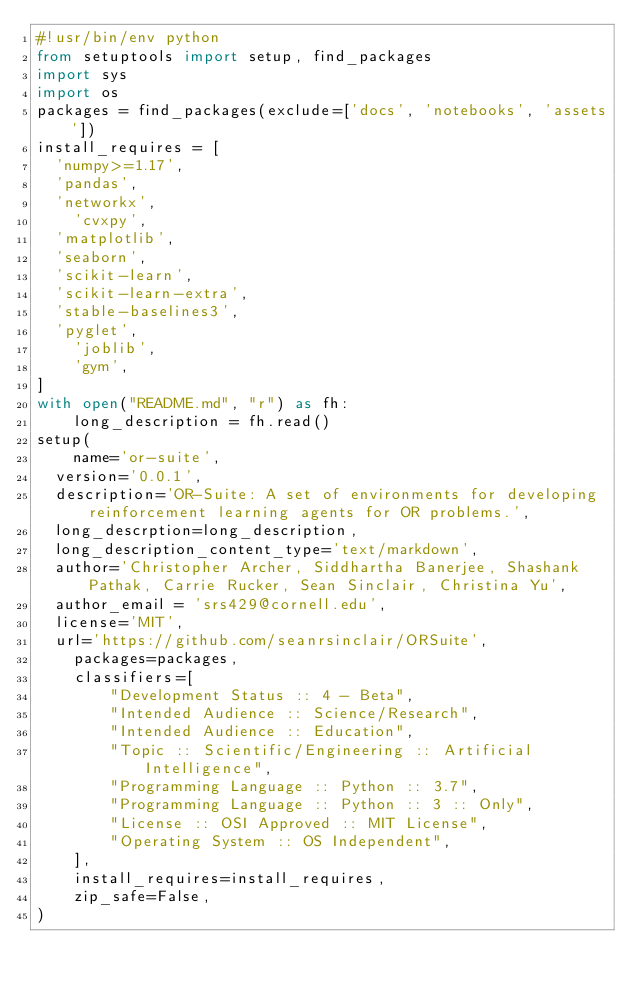Convert code to text. <code><loc_0><loc_0><loc_500><loc_500><_Python_>#!usr/bin/env python
from setuptools import setup, find_packages
import sys
import os
packages = find_packages(exclude=['docs', 'notebooks', 'assets'])
install_requires = [
	'numpy>=1.17',
	'pandas',
	'networkx',
    'cvxpy',
	'matplotlib',
	'seaborn',
	'scikit-learn',
	'scikit-learn-extra',
	'stable-baselines3',
	'pyglet',
    'joblib',
    'gym',
]
with open("README.md", "r") as fh:
    long_description = fh.read()
setup(
    name='or-suite',
	version='0.0.1',
	description='OR-Suite: A set of environments for developing reinforcement learning agents for OR problems.',
	long_descrption=long_description,
	long_description_content_type='text/markdown',
	author='Christopher Archer, Siddhartha Banerjee, Shashank Pathak, Carrie Rucker, Sean Sinclair, Christina Yu',
	author_email = 'srs429@cornell.edu',
	license='MIT',
	url='https://github.com/seanrsinclair/ORSuite',
    packages=packages,
    classifiers=[
        "Development Status :: 4 - Beta",
        "Intended Audience :: Science/Research",
        "Intended Audience :: Education",
        "Topic :: Scientific/Engineering :: Artificial Intelligence",
        "Programming Language :: Python :: 3.7",
        "Programming Language :: Python :: 3 :: Only",
        "License :: OSI Approved :: MIT License",
        "Operating System :: OS Independent",
    ],
    install_requires=install_requires,
    zip_safe=False,
)
</code> 